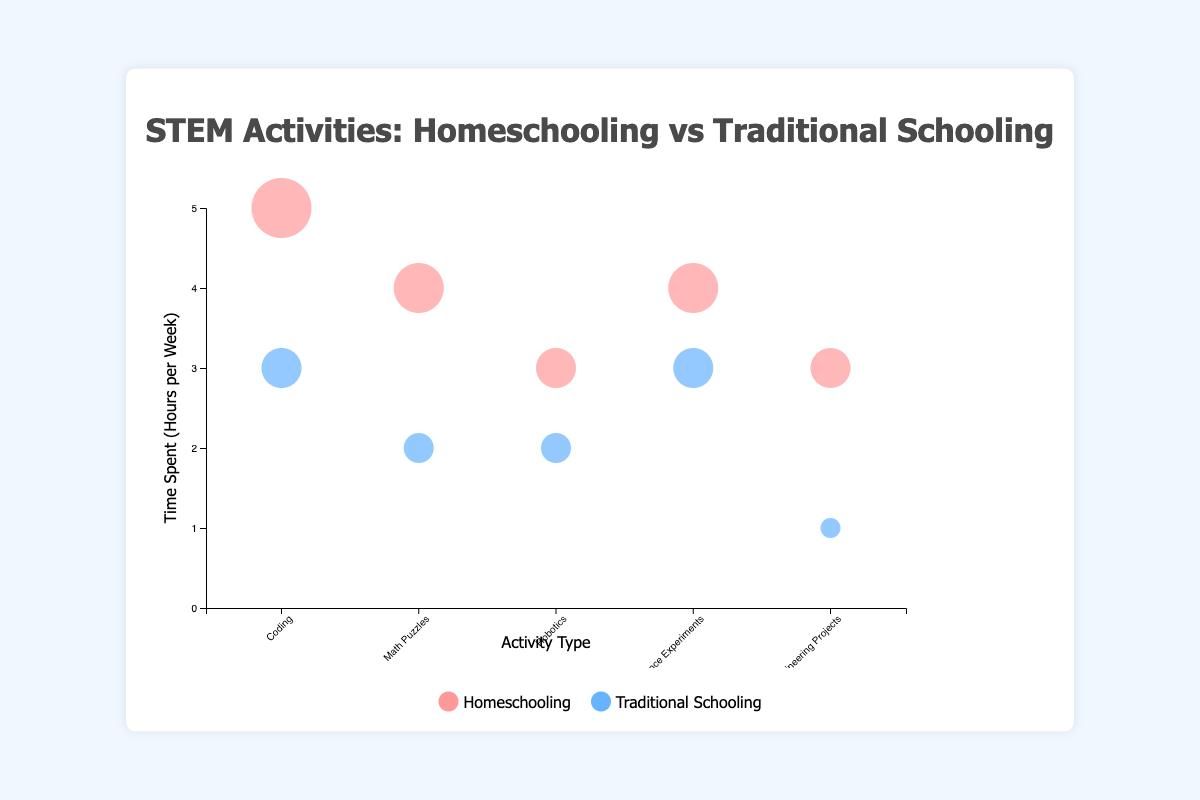What's the title of the figure? The title of the figure is prominently displayed at the top. It reads "STEM Activities: Homeschooling vs Traditional Schooling."
Answer: STEM Activities: Homeschooling vs Traditional Schooling What is the overall trend in time spent on Coding for Homeschooling versus Traditional Schooling? By examining the bubbles representing "Coding," we see that the bubble for Homeschooling is larger than the one for Traditional Schooling. This visually indicates that more time is spent on Coding in Homeschooling.
Answer: More time is spent on Coding in Homeschooling How many hours per week are spent on Math Puzzles in Homeschooling versus Traditional Schooling? The label for Math Puzzles shows bubbles with titles indicating time spent, with Homeschooling at 4 hours per week and Traditional Schooling at 2 hours per week.
Answer: Homeschooling: 4 hours, Traditional Schooling: 2 hours For which activity type is the time spent equal between Homeschooling and Traditional Schooling? None of the activity types have equal-sized bubbles among the listed activities, indicating no equal time spent.
Answer: None Which activity has the highest difficulty level and how much time is spent on it in Homeschooling? The ActivityType "Math Puzzles" and "Engineering Projects" have the highest difficulty level marked as "Advanced". For "Math Puzzles," 4 hours per week is spent in Homeschooling and for "Engineering Projects," 3 hours per week is spent in Homeschooling.
Answer: Math Puzzles (4 hours) and Engineering Projects (3 hours) Compare the time spent on Science Experiments in Homeschooling and Traditional Schooling. The bubbles for Science Experiments show Homeschooling at 4 hours per week and Traditional Schooling at 3 hours per week, as indicated by the titles.
Answer: Homeschooling: 4 hours, Traditional Schooling: 3 hours What is the total time spent on Robotics in both Homeschooling and Traditional Schooling? Adding the time spent on Robotics for Homeschooling (3 hours) and Traditional Schooling (2 hours), the total is 3 + 2 = 5 hours.
Answer: 5 hours Which has a larger bubble, Coding in Traditional Schooling or Robotics in Homeschooling, and what does it signify? The bubble for Robotics in Homeschooling (3 hours) is marginally larger than Coding in Traditional Schooling (3 hours). This signifies that slightly more time is spent on Robotics than on Coding in Traditional Schooling according to this dataset.
Answer: Robotics in Homeschooling What can you infer about the difficulty levels across all activities and educational approaches? In Homeschooling, the activities "Math Puzzles" and "Engineering Projects" have the advanced difficulty level while Traditional Schooling shows the same difficulty for these activities. Other activities fall under Intermediate or Beginner. This indicates variation in the complexity of activities across different educational approaches.
Answer: Varies across activities 